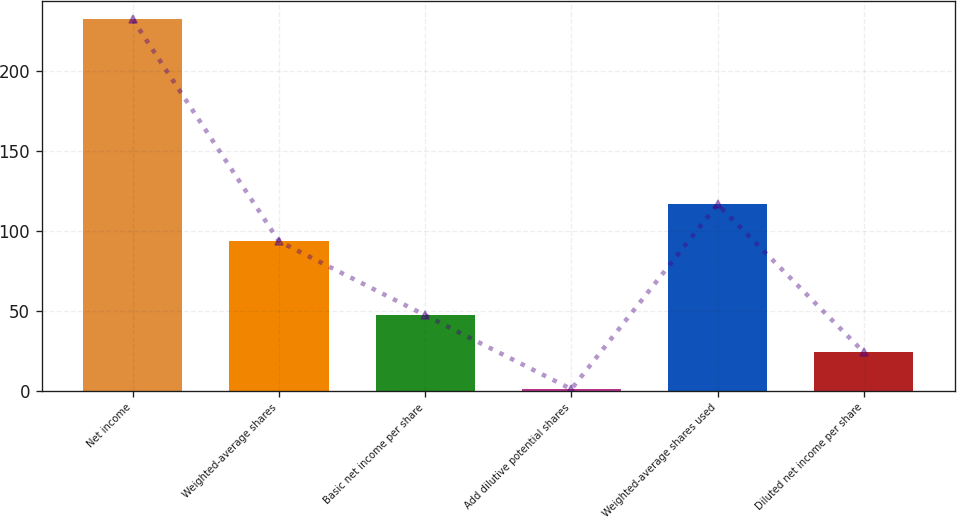Convert chart. <chart><loc_0><loc_0><loc_500><loc_500><bar_chart><fcel>Net income<fcel>Weighted-average shares<fcel>Basic net income per share<fcel>Add dilutive potential shares<fcel>Weighted-average shares used<fcel>Diluted net income per share<nl><fcel>232.6<fcel>93.58<fcel>47.24<fcel>0.9<fcel>116.75<fcel>24.07<nl></chart> 